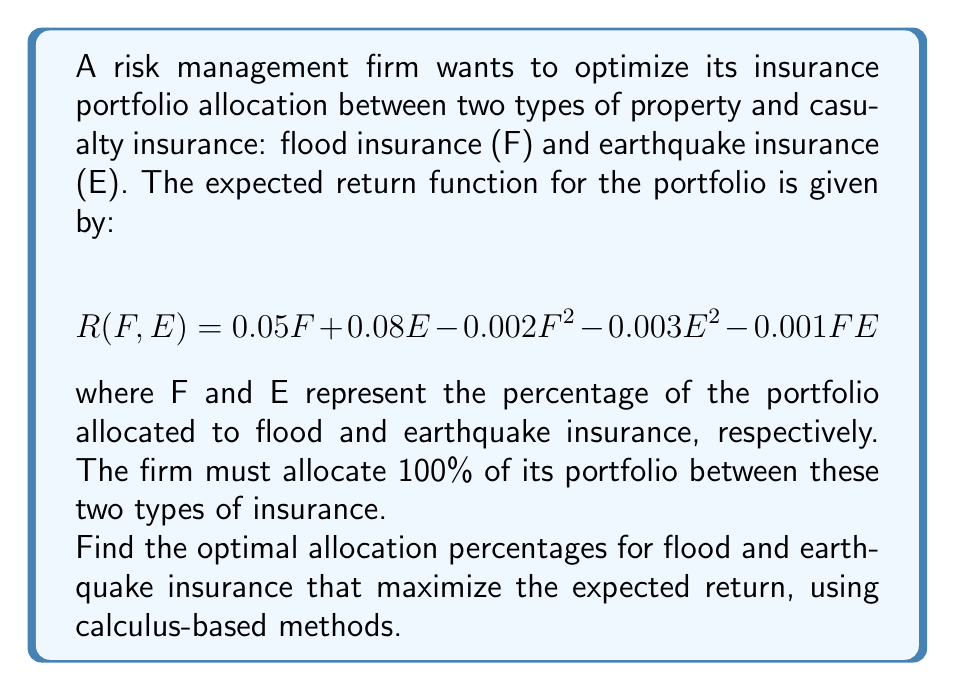Could you help me with this problem? To solve this optimization problem, we'll use the method of Lagrange multipliers:

1) First, we set up the Lagrangian function:
   $$L(F, E, \lambda) = R(F, E) - \lambda(F + E - 100)$$
   $$L(F, E, \lambda) = 0.05F + 0.08E - 0.002F^2 - 0.003E^2 - 0.001FE - \lambda(F + E - 100)$$

2) Now, we take partial derivatives and set them equal to zero:
   $$\frac{\partial L}{\partial F} = 0.05 - 0.004F - 0.001E - \lambda = 0$$
   $$\frac{\partial L}{\partial E} = 0.08 - 0.006E - 0.001F - \lambda = 0$$
   $$\frac{\partial L}{\partial \lambda} = F + E - 100 = 0$$

3) From the first two equations:
   $$0.05 - 0.004F - 0.001E = \lambda$$
   $$0.08 - 0.006E - 0.001F = \lambda$$

4) Equating these:
   $$0.05 - 0.004F - 0.001E = 0.08 - 0.006E - 0.001F$$
   $$-0.03 + 0.003F = -0.005E$$
   $$0.003F + 0.005E = 0.03$$

5) Combining this with $F + E = 100$ from step 3, we have a system of two equations:
   $$0.003F + 0.005E = 0.03$$
   $$F + E = 100$$

6) Solving this system:
   Multiply the first equation by 200 and the second by 0.005:
   $$0.6F + E = 6$$
   $$0.005F + 0.005E = 0.5$$
   
   Subtracting the second from the first:
   $$0.595F = 5.5$$
   $$F \approx 92.44$$

7) Substituting this back into $F + E = 100$:
   $$E \approx 7.56$$

Therefore, the optimal allocation is approximately 92.44% to flood insurance and 7.56% to earthquake insurance.
Answer: Flood insurance: 92.44%, Earthquake insurance: 7.56% 